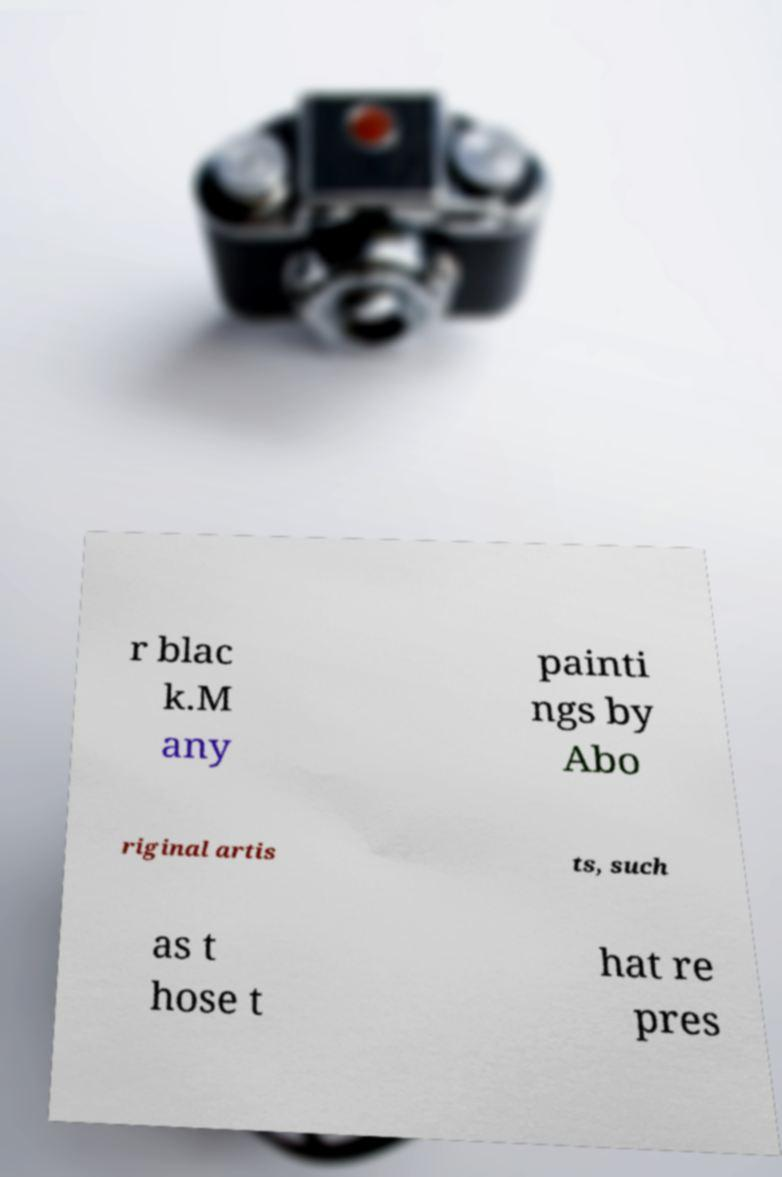Could you extract and type out the text from this image? r blac k.M any painti ngs by Abo riginal artis ts, such as t hose t hat re pres 